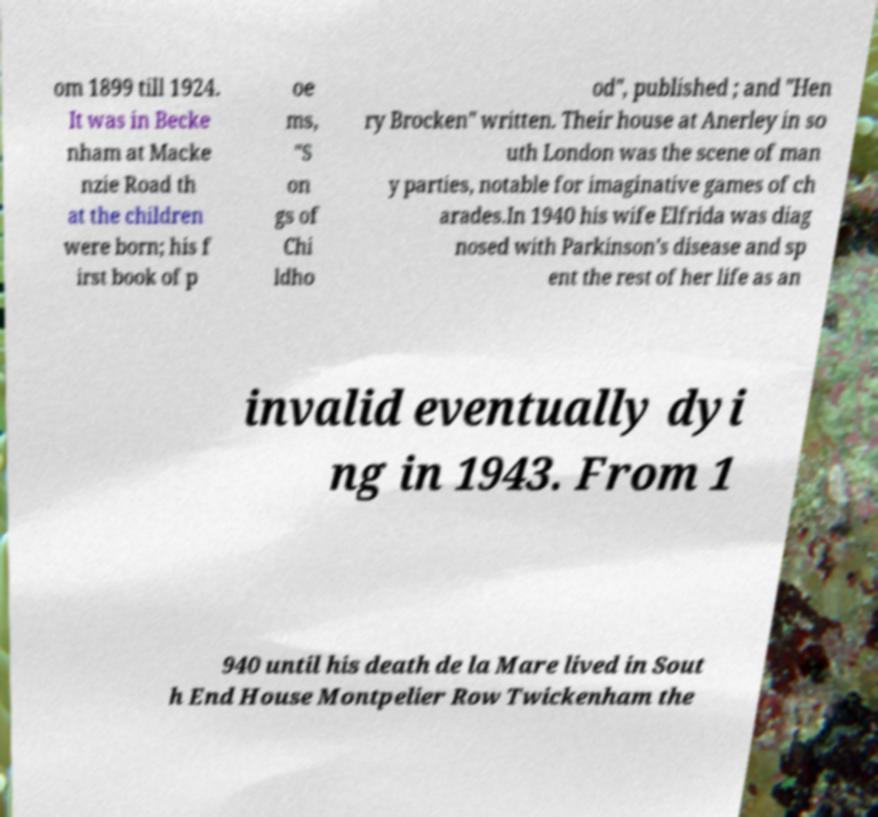For documentation purposes, I need the text within this image transcribed. Could you provide that? om 1899 till 1924. It was in Becke nham at Macke nzie Road th at the children were born; his f irst book of p oe ms, "S on gs of Chi ldho od", published ; and "Hen ry Brocken" written. Their house at Anerley in so uth London was the scene of man y parties, notable for imaginative games of ch arades.In 1940 his wife Elfrida was diag nosed with Parkinson's disease and sp ent the rest of her life as an invalid eventually dyi ng in 1943. From 1 940 until his death de la Mare lived in Sout h End House Montpelier Row Twickenham the 